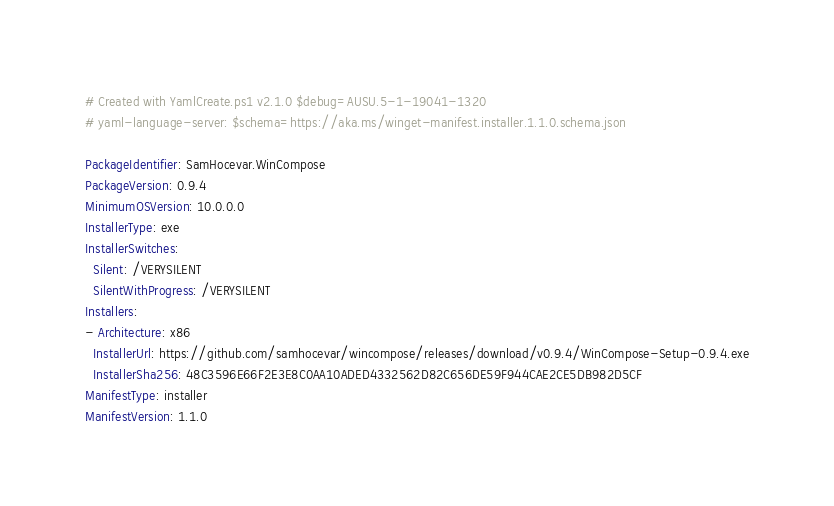<code> <loc_0><loc_0><loc_500><loc_500><_YAML_># Created with YamlCreate.ps1 v2.1.0 $debug=AUSU.5-1-19041-1320
# yaml-language-server: $schema=https://aka.ms/winget-manifest.installer.1.1.0.schema.json

PackageIdentifier: SamHocevar.WinCompose
PackageVersion: 0.9.4
MinimumOSVersion: 10.0.0.0
InstallerType: exe
InstallerSwitches:
  Silent: /VERYSILENT
  SilentWithProgress: /VERYSILENT
Installers:
- Architecture: x86
  InstallerUrl: https://github.com/samhocevar/wincompose/releases/download/v0.9.4/WinCompose-Setup-0.9.4.exe
  InstallerSha256: 48C3596E66F2E3E8C0AA10ADED4332562D82C656DE59F944CAE2CE5DB982D5CF
ManifestType: installer
ManifestVersion: 1.1.0
</code> 